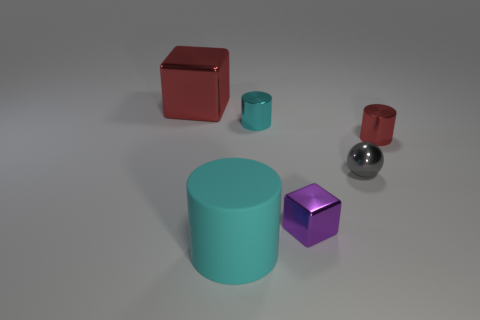Is there any other thing that has the same material as the large cyan cylinder?
Your answer should be very brief. No. What is the color of the cylinder right of the block in front of the small gray thing?
Ensure brevity in your answer.  Red. There is a block that is the same size as the red cylinder; what is its color?
Provide a short and direct response. Purple. What number of large things are either metallic objects or red rubber cylinders?
Provide a short and direct response. 1. Are there more spheres that are behind the small red shiny object than small purple shiny objects that are left of the tiny cyan cylinder?
Provide a short and direct response. No. How many other objects are the same size as the red block?
Your response must be concise. 1. Is the material of the tiny red cylinder that is behind the metallic ball the same as the big cyan thing?
Provide a short and direct response. No. How many other objects are there of the same color as the matte thing?
Your answer should be compact. 1. What number of other things are the same shape as the small purple object?
Ensure brevity in your answer.  1. There is a small object left of the small purple shiny object; does it have the same shape as the red thing to the right of the red shiny block?
Ensure brevity in your answer.  Yes. 